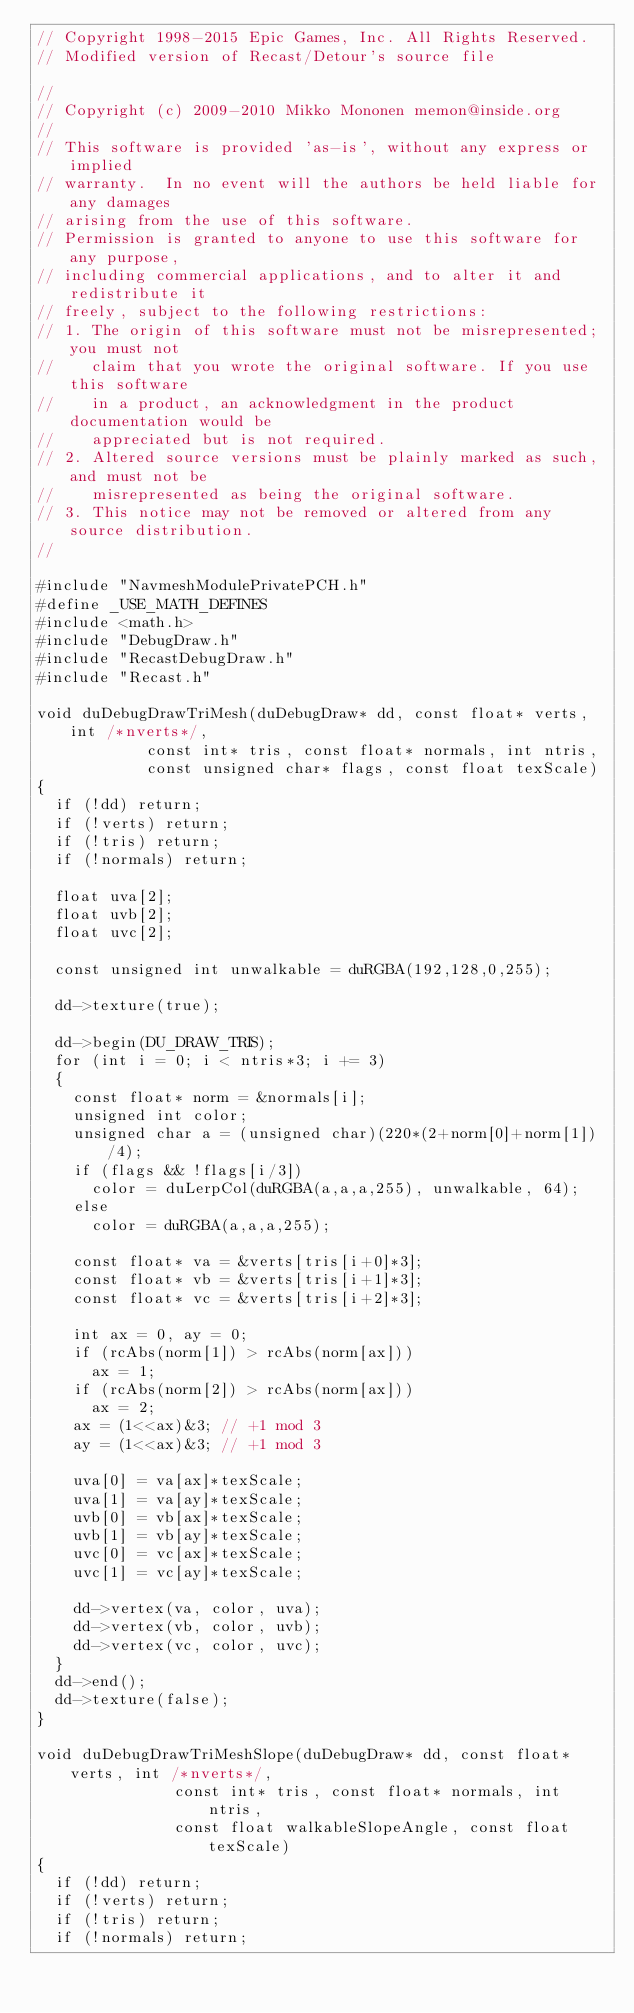<code> <loc_0><loc_0><loc_500><loc_500><_C++_>// Copyright 1998-2015 Epic Games, Inc. All Rights Reserved.
// Modified version of Recast/Detour's source file

//
// Copyright (c) 2009-2010 Mikko Mononen memon@inside.org
//
// This software is provided 'as-is', without any express or implied
// warranty.  In no event will the authors be held liable for any damages
// arising from the use of this software.
// Permission is granted to anyone to use this software for any purpose,
// including commercial applications, and to alter it and redistribute it
// freely, subject to the following restrictions:
// 1. The origin of this software must not be misrepresented; you must not
//    claim that you wrote the original software. If you use this software
//    in a product, an acknowledgment in the product documentation would be
//    appreciated but is not required.
// 2. Altered source versions must be plainly marked as such, and must not be
//    misrepresented as being the original software.
// 3. This notice may not be removed or altered from any source distribution.
//

#include "NavmeshModulePrivatePCH.h"
#define _USE_MATH_DEFINES
#include <math.h>
#include "DebugDraw.h"
#include "RecastDebugDraw.h"
#include "Recast.h"

void duDebugDrawTriMesh(duDebugDraw* dd, const float* verts, int /*nverts*/,
						const int* tris, const float* normals, int ntris,
						const unsigned char* flags, const float texScale)
{
	if (!dd) return;
	if (!verts) return;
	if (!tris) return;
	if (!normals) return;

	float uva[2];
	float uvb[2];
	float uvc[2];

	const unsigned int unwalkable = duRGBA(192,128,0,255);

	dd->texture(true);

	dd->begin(DU_DRAW_TRIS);
	for (int i = 0; i < ntris*3; i += 3)
	{
		const float* norm = &normals[i];
		unsigned int color;
		unsigned char a = (unsigned char)(220*(2+norm[0]+norm[1])/4);
		if (flags && !flags[i/3])
			color = duLerpCol(duRGBA(a,a,a,255), unwalkable, 64);
		else
			color = duRGBA(a,a,a,255);

		const float* va = &verts[tris[i+0]*3];
		const float* vb = &verts[tris[i+1]*3];
		const float* vc = &verts[tris[i+2]*3];
		
		int ax = 0, ay = 0;
		if (rcAbs(norm[1]) > rcAbs(norm[ax]))
			ax = 1;
		if (rcAbs(norm[2]) > rcAbs(norm[ax]))
			ax = 2;
		ax = (1<<ax)&3; // +1 mod 3
		ay = (1<<ax)&3; // +1 mod 3

		uva[0] = va[ax]*texScale;
		uva[1] = va[ay]*texScale;
		uvb[0] = vb[ax]*texScale;
		uvb[1] = vb[ay]*texScale;
		uvc[0] = vc[ax]*texScale;
		uvc[1] = vc[ay]*texScale;
		
		dd->vertex(va, color, uva);
		dd->vertex(vb, color, uvb);
		dd->vertex(vc, color, uvc);
	}
	dd->end();
	dd->texture(false);
}

void duDebugDrawTriMeshSlope(duDebugDraw* dd, const float* verts, int /*nverts*/,
							 const int* tris, const float* normals, int ntris,
							 const float walkableSlopeAngle, const float texScale)
{
	if (!dd) return;
	if (!verts) return;
	if (!tris) return;
	if (!normals) return;
	</code> 